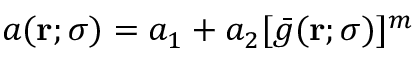<formula> <loc_0><loc_0><loc_500><loc_500>a ( r ; \sigma ) = a _ { 1 } + a _ { 2 } [ \bar { g } ( r ; \sigma ) ] ^ { m }</formula> 